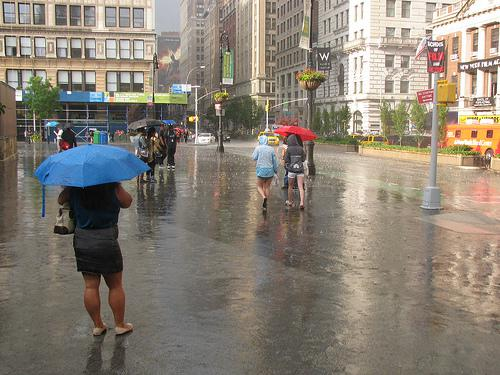Question: where are the people?
Choices:
A. Street.
B. Sidewalk.
C. Benches.
D. On chairs.
Answer with the letter. Answer: B Question: why are they holding umbrellas?
Choices:
A. It's sunny.
B. It's snowing.
C. It's cloudy.
D. It's raining.
Answer with the letter. Answer: D Question: what is on the floor?
Choices:
A. Sand.
B. Water.
C. Grass.
D. Gravel.
Answer with the letter. Answer: B Question: who is getting wet?
Choices:
A. People.
B. Dogs.
C. Cats.
D. Kids.
Answer with the letter. Answer: A 